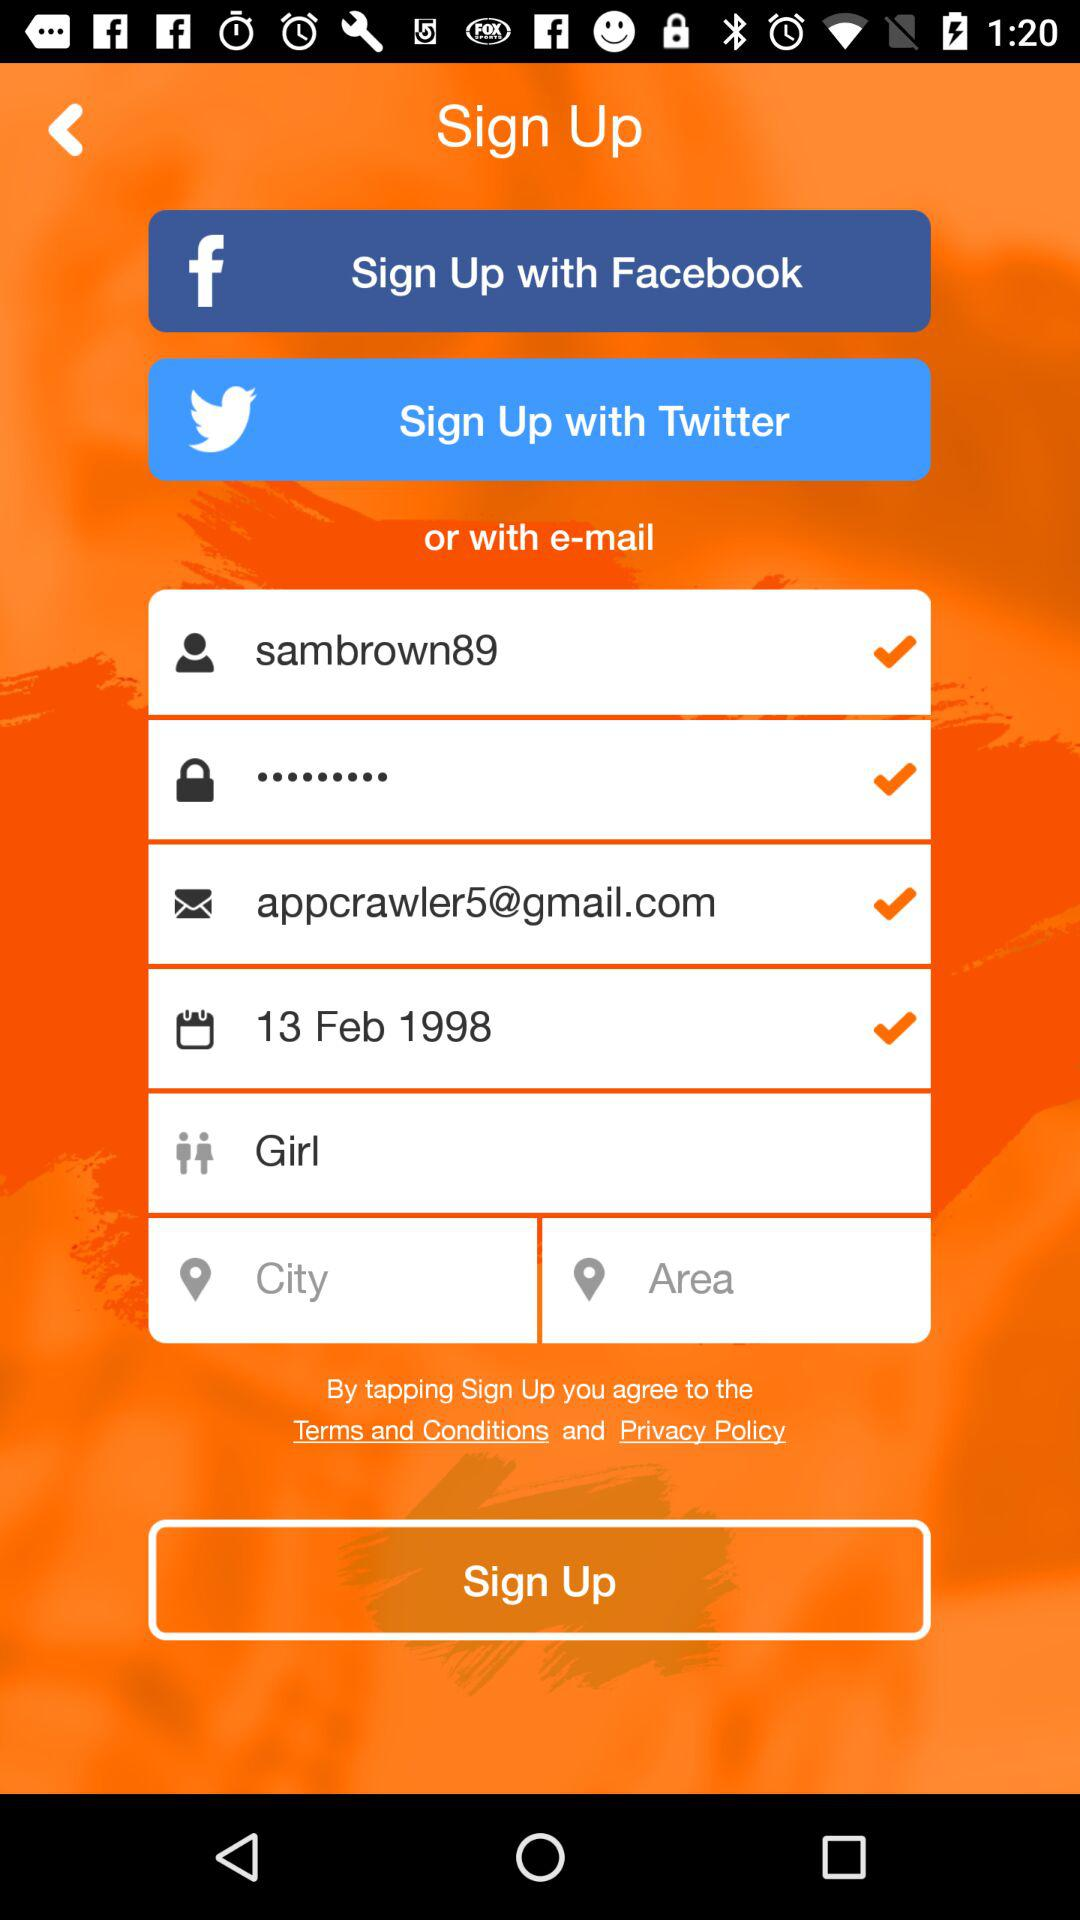What is the email address? The email address is appcrawler5@gmail.com. 